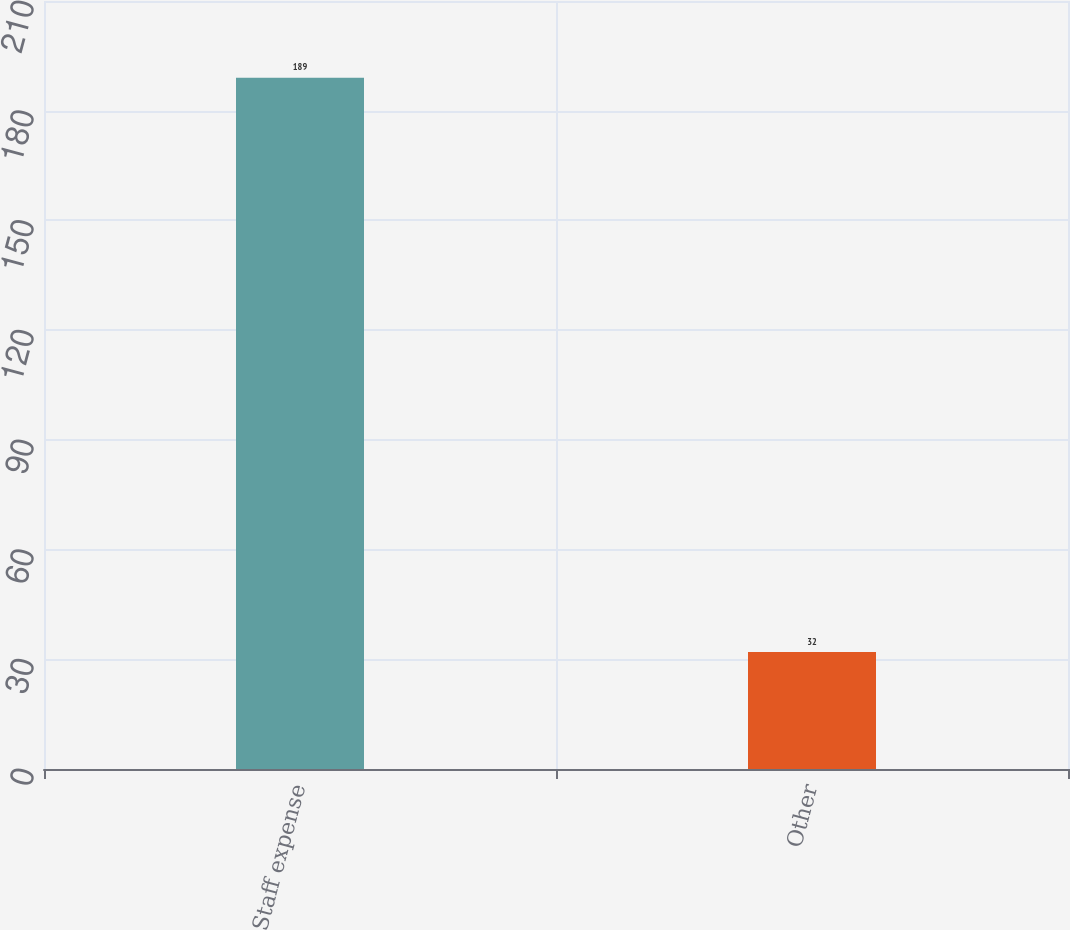<chart> <loc_0><loc_0><loc_500><loc_500><bar_chart><fcel>Staff expense<fcel>Other<nl><fcel>189<fcel>32<nl></chart> 